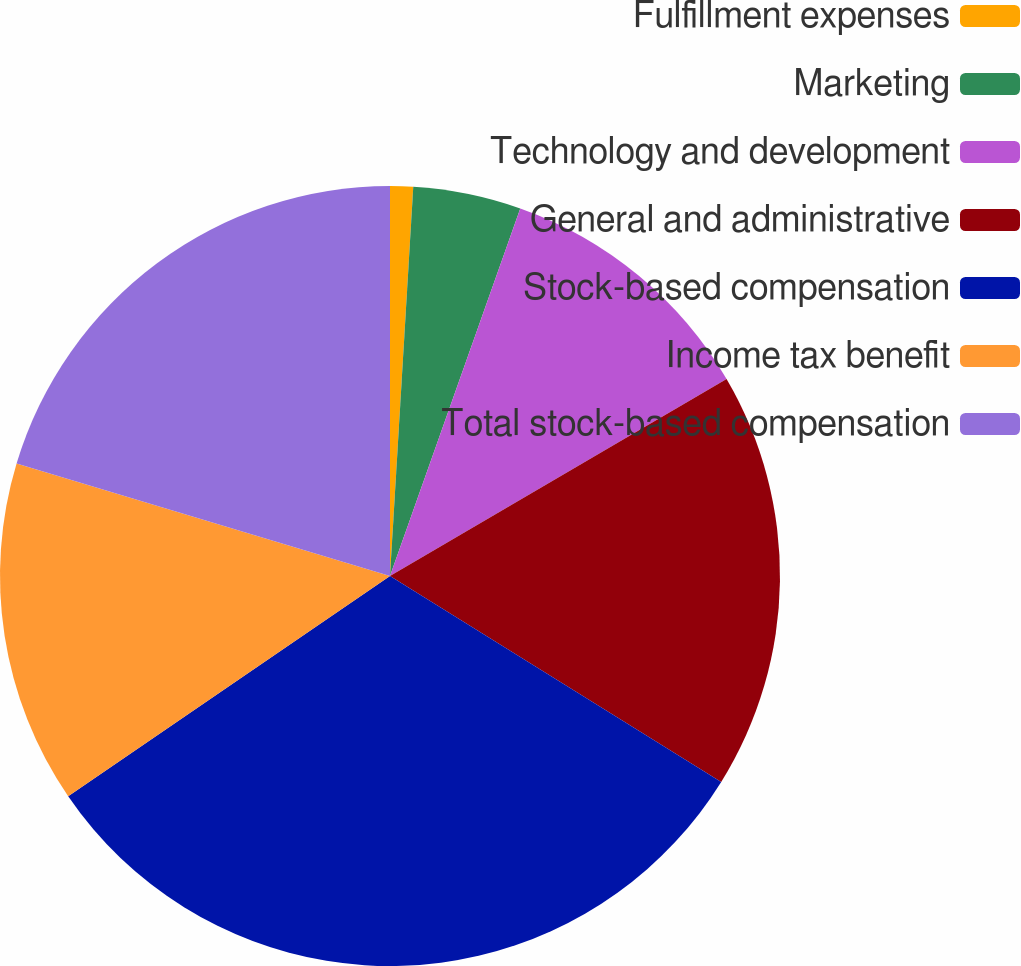Convert chart. <chart><loc_0><loc_0><loc_500><loc_500><pie_chart><fcel>Fulfillment expenses<fcel>Marketing<fcel>Technology and development<fcel>General and administrative<fcel>Stock-based compensation<fcel>Income tax benefit<fcel>Total stock-based compensation<nl><fcel>0.95%<fcel>4.47%<fcel>11.15%<fcel>17.28%<fcel>31.59%<fcel>14.21%<fcel>20.34%<nl></chart> 